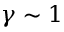Convert formula to latex. <formula><loc_0><loc_0><loc_500><loc_500>\gamma \sim 1</formula> 